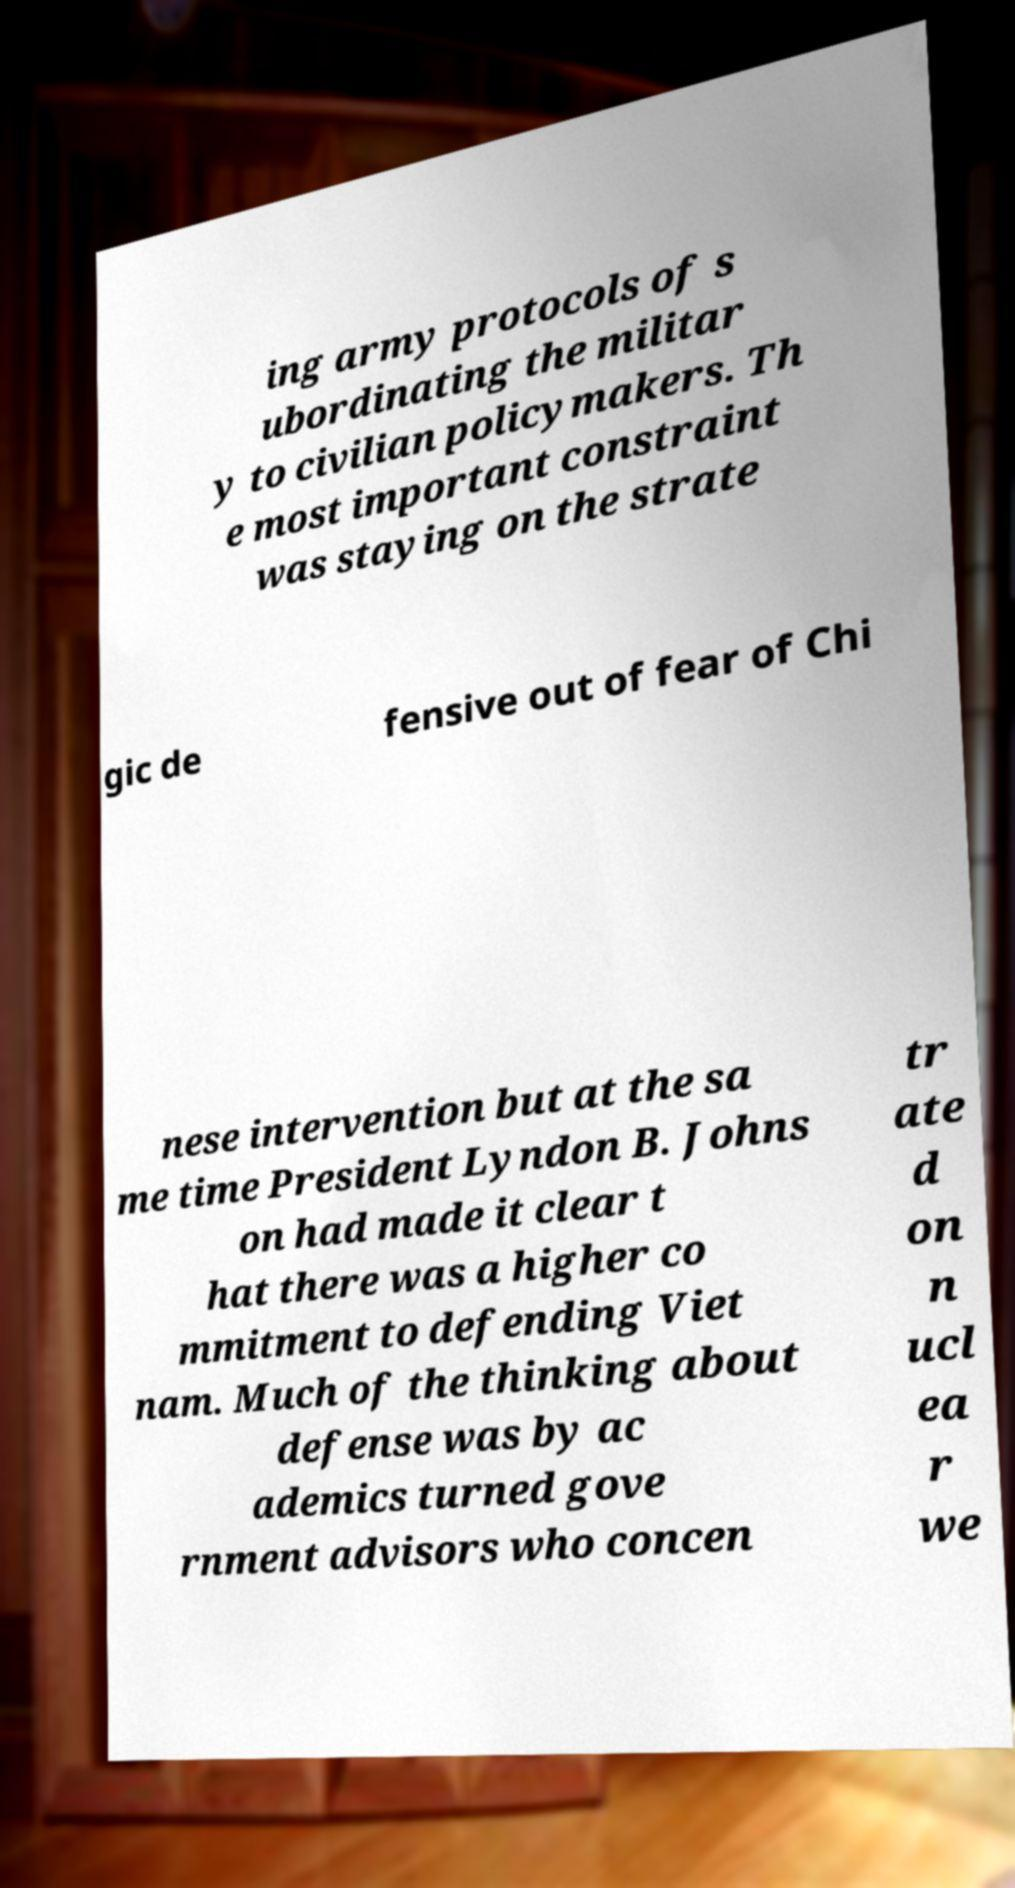For documentation purposes, I need the text within this image transcribed. Could you provide that? ing army protocols of s ubordinating the militar y to civilian policymakers. Th e most important constraint was staying on the strate gic de fensive out of fear of Chi nese intervention but at the sa me time President Lyndon B. Johns on had made it clear t hat there was a higher co mmitment to defending Viet nam. Much of the thinking about defense was by ac ademics turned gove rnment advisors who concen tr ate d on n ucl ea r we 